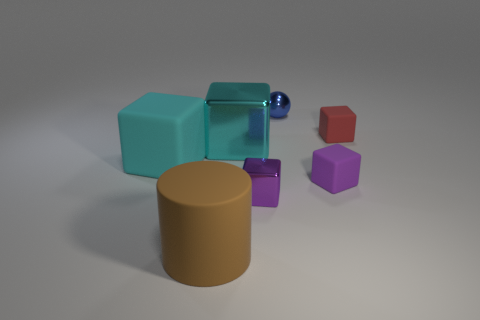Subtract all small purple rubber blocks. How many blocks are left? 4 Subtract 5 blocks. How many blocks are left? 0 Add 2 matte objects. How many objects exist? 9 Subtract all red blocks. How many blocks are left? 4 Subtract all brown cubes. How many blue cylinders are left? 0 Subtract all small purple rubber cubes. Subtract all tiny blue things. How many objects are left? 5 Add 6 purple rubber blocks. How many purple rubber blocks are left? 7 Add 1 green metallic cylinders. How many green metallic cylinders exist? 1 Subtract 0 yellow cylinders. How many objects are left? 7 Subtract all cylinders. How many objects are left? 6 